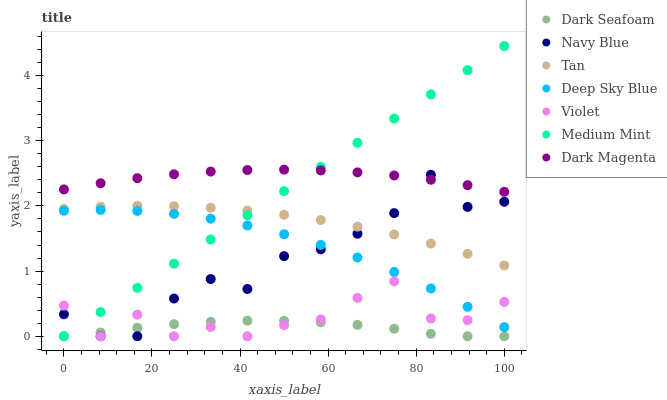Does Dark Seafoam have the minimum area under the curve?
Answer yes or no. Yes. Does Dark Magenta have the maximum area under the curve?
Answer yes or no. Yes. Does Navy Blue have the minimum area under the curve?
Answer yes or no. No. Does Navy Blue have the maximum area under the curve?
Answer yes or no. No. Is Medium Mint the smoothest?
Answer yes or no. Yes. Is Navy Blue the roughest?
Answer yes or no. Yes. Is Dark Magenta the smoothest?
Answer yes or no. No. Is Dark Magenta the roughest?
Answer yes or no. No. Does Medium Mint have the lowest value?
Answer yes or no. Yes. Does Dark Magenta have the lowest value?
Answer yes or no. No. Does Medium Mint have the highest value?
Answer yes or no. Yes. Does Dark Magenta have the highest value?
Answer yes or no. No. Is Violet less than Dark Magenta?
Answer yes or no. Yes. Is Dark Magenta greater than Violet?
Answer yes or no. Yes. Does Navy Blue intersect Tan?
Answer yes or no. Yes. Is Navy Blue less than Tan?
Answer yes or no. No. Is Navy Blue greater than Tan?
Answer yes or no. No. Does Violet intersect Dark Magenta?
Answer yes or no. No. 